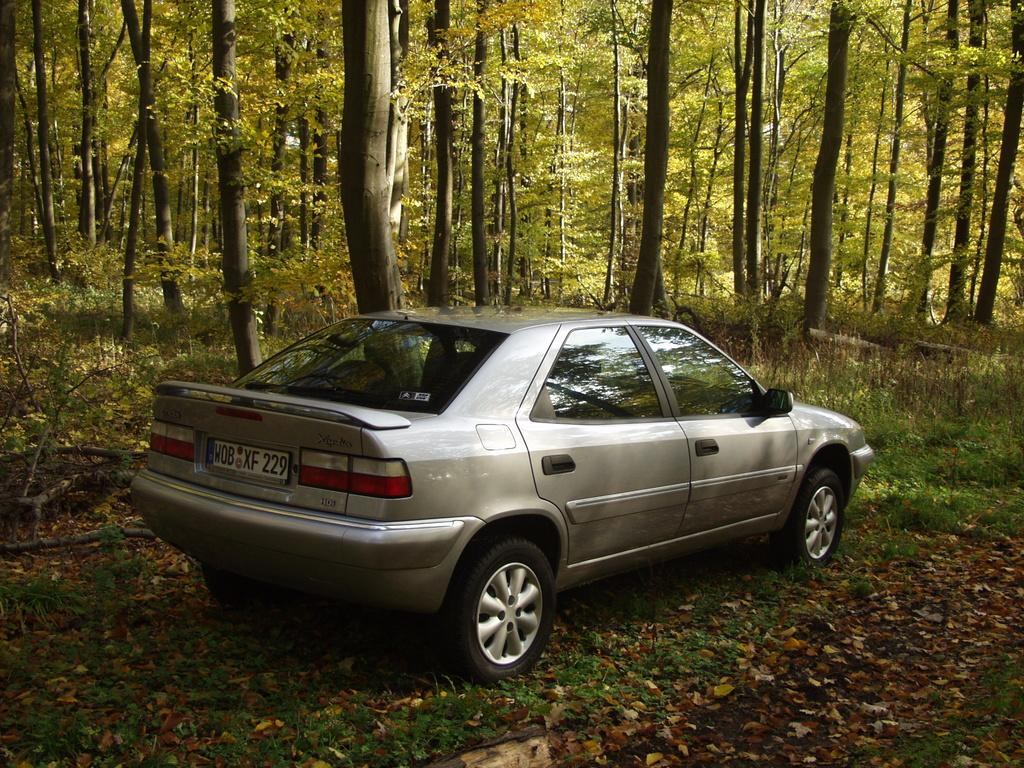What types of objects can be seen in the image? There are vehicles in the image. What can be seen behind the vehicles in the image? There are trees behind the vehicles in the image. What type of thing is exhibiting unusual behavior with its foot in the image? There is no object or creature in the image that has a foot or is exhibiting unusual behavior. 